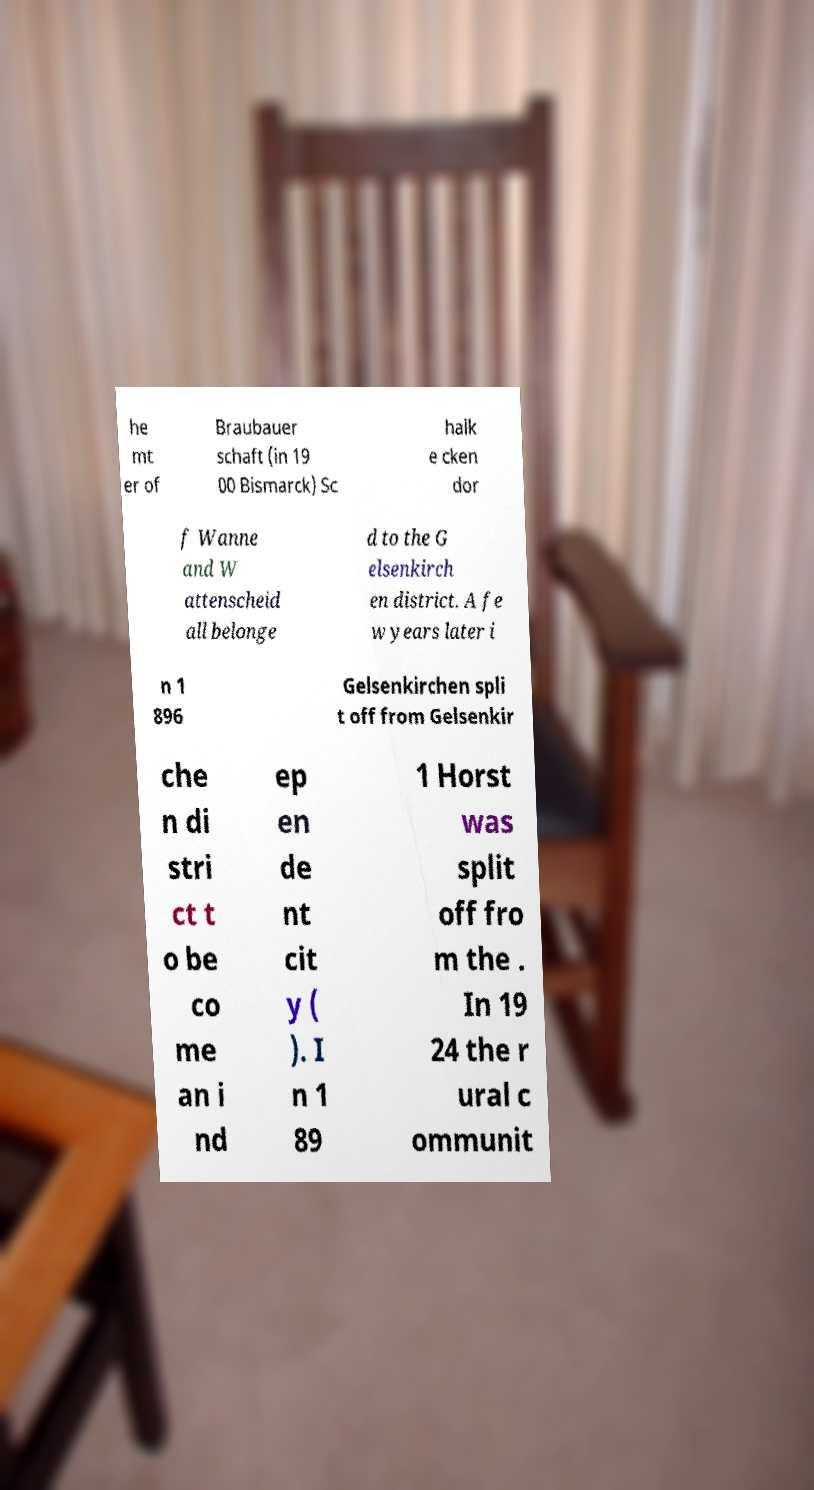For documentation purposes, I need the text within this image transcribed. Could you provide that? he mt er of Braubauer schaft (in 19 00 Bismarck) Sc halk e cken dor f Wanne and W attenscheid all belonge d to the G elsenkirch en district. A fe w years later i n 1 896 Gelsenkirchen spli t off from Gelsenkir che n di stri ct t o be co me an i nd ep en de nt cit y ( ). I n 1 89 1 Horst was split off fro m the . In 19 24 the r ural c ommunit 